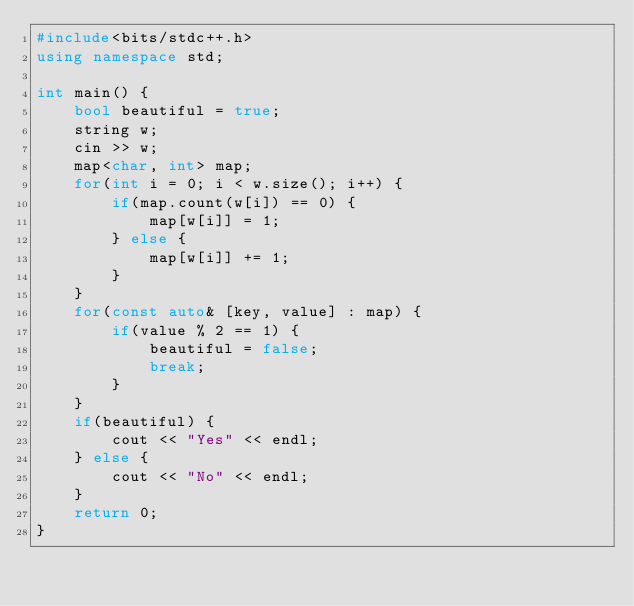<code> <loc_0><loc_0><loc_500><loc_500><_C++_>#include<bits/stdc++.h>
using namespace std;

int main() {
    bool beautiful = true;
    string w;
    cin >> w;
    map<char, int> map;
    for(int i = 0; i < w.size(); i++) {
        if(map.count(w[i]) == 0) {
            map[w[i]] = 1;
        } else {
            map[w[i]] += 1;
        }
    }
    for(const auto& [key, value] : map) {
        if(value % 2 == 1) {
            beautiful = false;
            break;
        }
    }
    if(beautiful) { 
        cout << "Yes" << endl; 
    } else {
        cout << "No" << endl;
    }
    return 0;
}</code> 